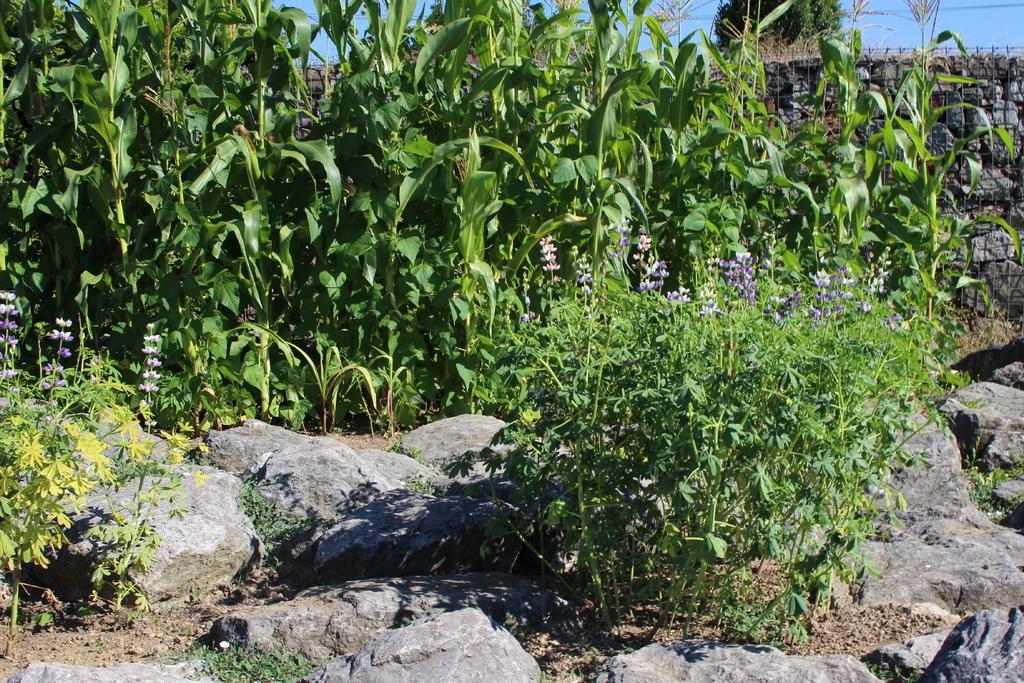Can you describe this image briefly? Here we can see rocks, plants, mesh and flowers. 